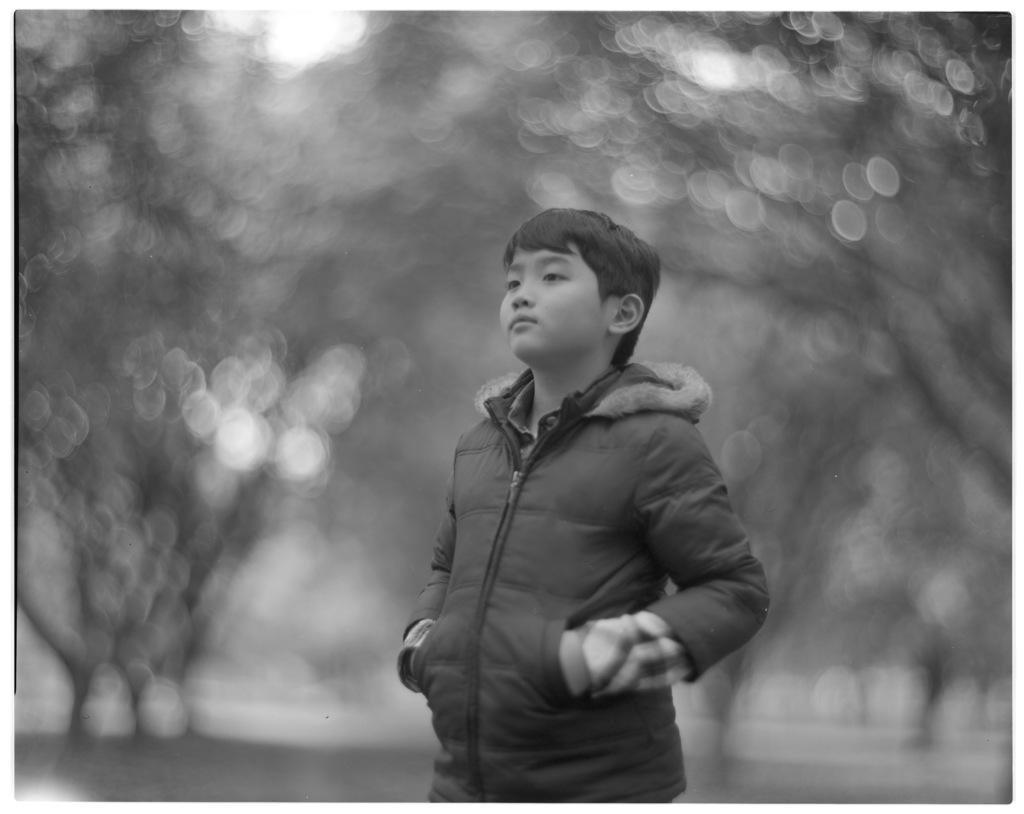What is the color scheme of the image? The image is black and white. What can be seen in the foreground of the image? There is a boy standing in the image. How would you describe the background of the image? The background of the image is blurred. What type of magic is the boy performing in the image? There is no indication of magic or any magical activity in the image. 